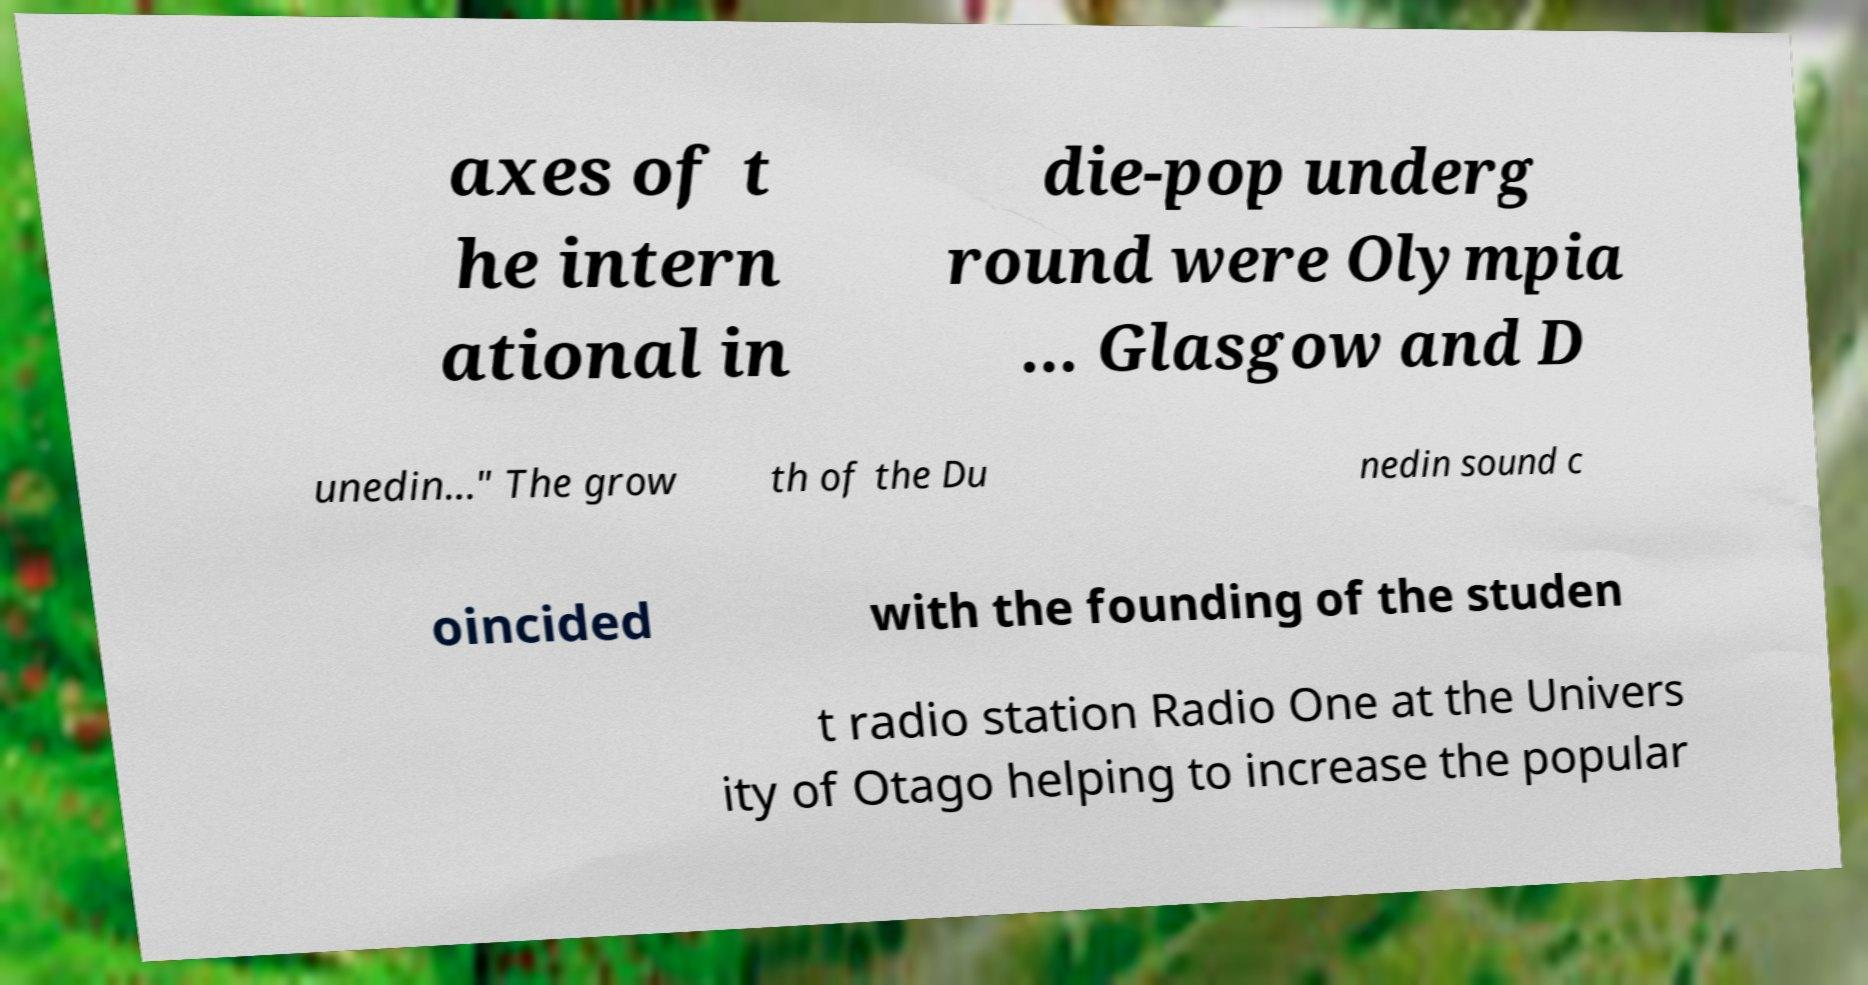Can you read and provide the text displayed in the image?This photo seems to have some interesting text. Can you extract and type it out for me? axes of t he intern ational in die-pop underg round were Olympia ... Glasgow and D unedin..." The grow th of the Du nedin sound c oincided with the founding of the studen t radio station Radio One at the Univers ity of Otago helping to increase the popular 